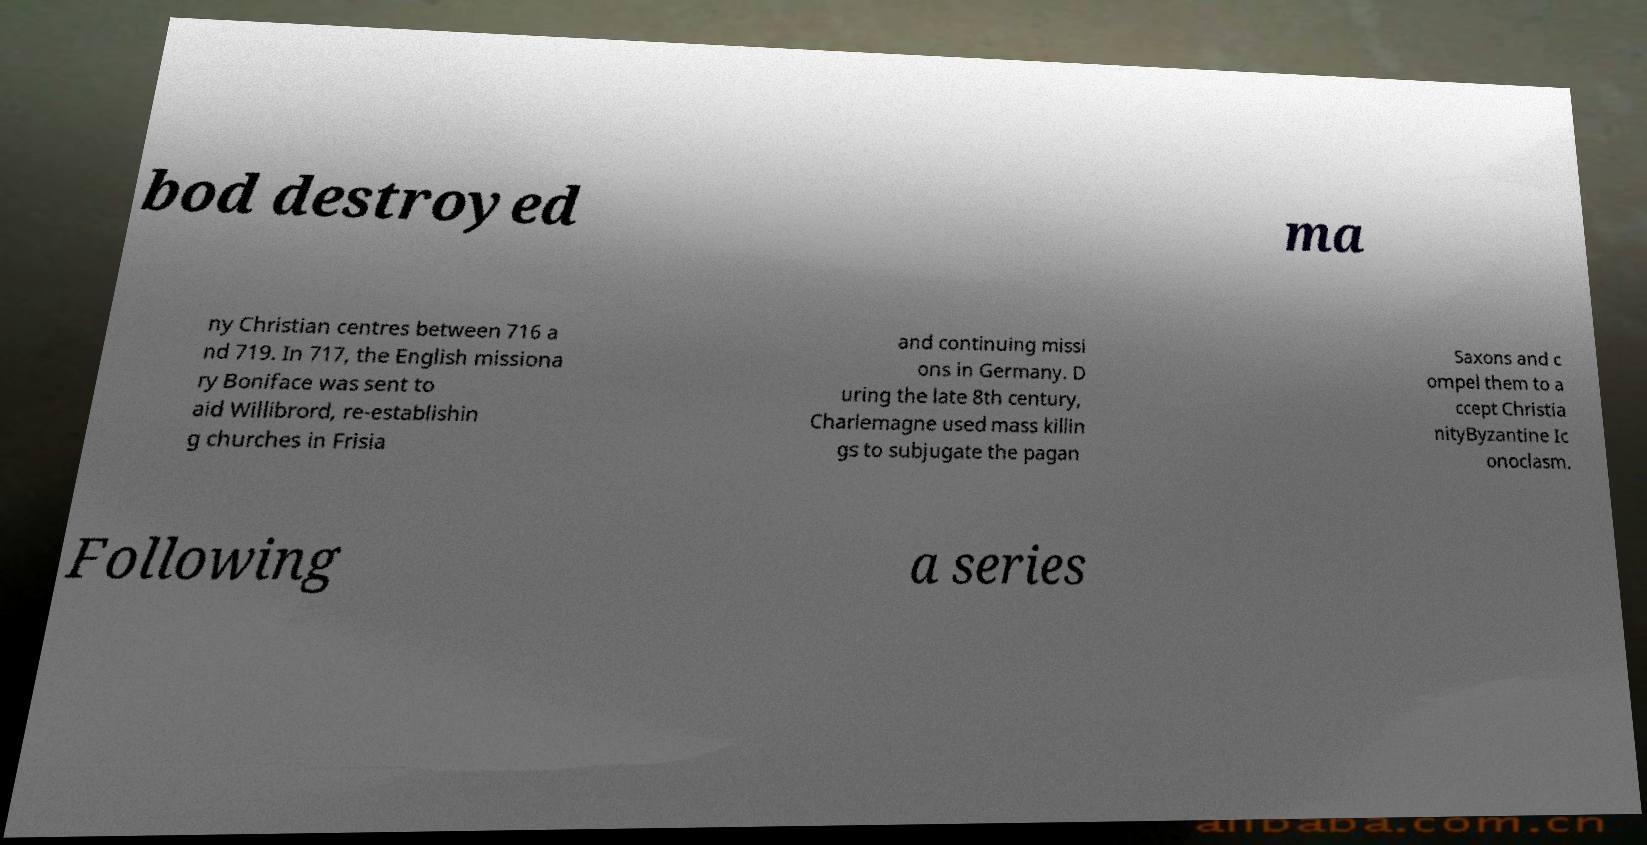There's text embedded in this image that I need extracted. Can you transcribe it verbatim? bod destroyed ma ny Christian centres between 716 a nd 719. In 717, the English missiona ry Boniface was sent to aid Willibrord, re-establishin g churches in Frisia and continuing missi ons in Germany. D uring the late 8th century, Charlemagne used mass killin gs to subjugate the pagan Saxons and c ompel them to a ccept Christia nityByzantine Ic onoclasm. Following a series 